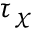Convert formula to latex. <formula><loc_0><loc_0><loc_500><loc_500>\tau _ { \chi }</formula> 